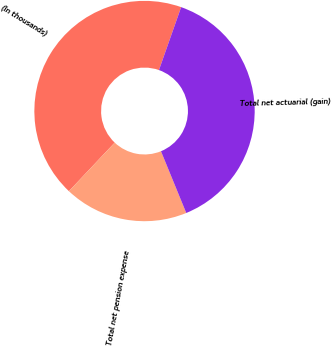<chart> <loc_0><loc_0><loc_500><loc_500><pie_chart><fcel>(In thousands)<fcel>Total net pension expense<fcel>Total net actuarial (gain)<nl><fcel>43.36%<fcel>18.22%<fcel>38.42%<nl></chart> 